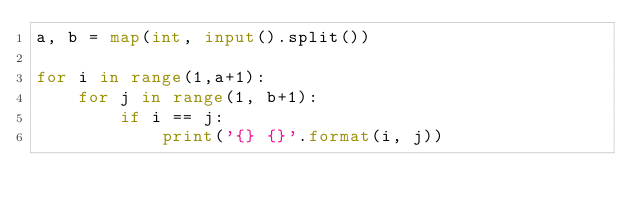Convert code to text. <code><loc_0><loc_0><loc_500><loc_500><_Python_>a, b = map(int, input().split())

for i in range(1,a+1):
    for j in range(1, b+1):
        if i == j:
            print('{} {}'.format(i, j))</code> 